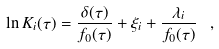<formula> <loc_0><loc_0><loc_500><loc_500>\ln K _ { i } ( \tau ) = \frac { \delta ( \tau ) } { f _ { 0 } ( \tau ) } + \xi _ { i } + \frac { \lambda _ { i } } { f _ { 0 } ( \tau ) } \ ,</formula> 